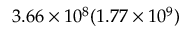<formula> <loc_0><loc_0><loc_500><loc_500>3 . 6 6 \times 1 0 ^ { 8 } ( 1 . 7 7 \times 1 0 ^ { 9 } )</formula> 